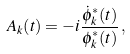<formula> <loc_0><loc_0><loc_500><loc_500>A _ { k } ( t ) = - i \frac { \dot { \phi } _ { k } ^ { * } ( t ) } { \phi _ { k } ^ { * } ( t ) } \, ,</formula> 